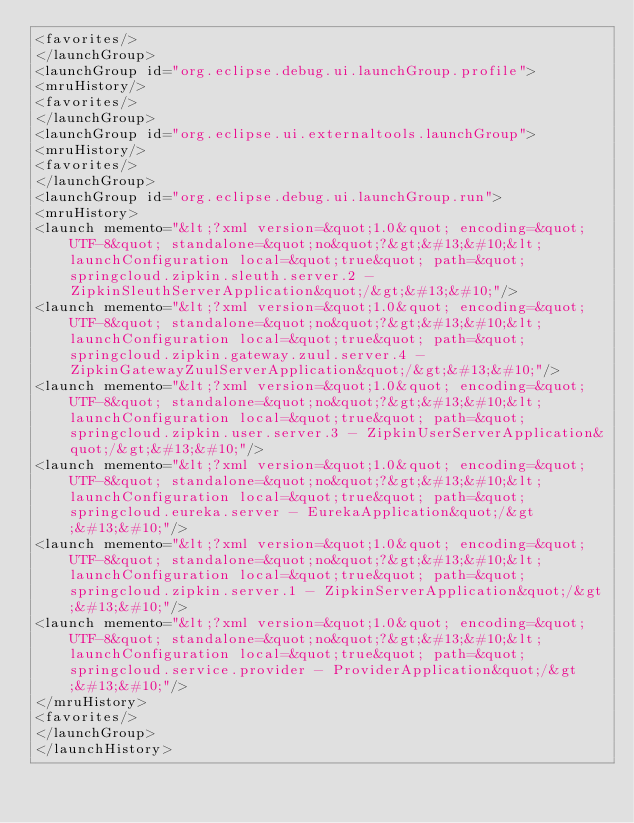Convert code to text. <code><loc_0><loc_0><loc_500><loc_500><_XML_><favorites/>
</launchGroup>
<launchGroup id="org.eclipse.debug.ui.launchGroup.profile">
<mruHistory/>
<favorites/>
</launchGroup>
<launchGroup id="org.eclipse.ui.externaltools.launchGroup">
<mruHistory/>
<favorites/>
</launchGroup>
<launchGroup id="org.eclipse.debug.ui.launchGroup.run">
<mruHistory>
<launch memento="&lt;?xml version=&quot;1.0&quot; encoding=&quot;UTF-8&quot; standalone=&quot;no&quot;?&gt;&#13;&#10;&lt;launchConfiguration local=&quot;true&quot; path=&quot;springcloud.zipkin.sleuth.server.2 - ZipkinSleuthServerApplication&quot;/&gt;&#13;&#10;"/>
<launch memento="&lt;?xml version=&quot;1.0&quot; encoding=&quot;UTF-8&quot; standalone=&quot;no&quot;?&gt;&#13;&#10;&lt;launchConfiguration local=&quot;true&quot; path=&quot;springcloud.zipkin.gateway.zuul.server.4 - ZipkinGatewayZuulServerApplication&quot;/&gt;&#13;&#10;"/>
<launch memento="&lt;?xml version=&quot;1.0&quot; encoding=&quot;UTF-8&quot; standalone=&quot;no&quot;?&gt;&#13;&#10;&lt;launchConfiguration local=&quot;true&quot; path=&quot;springcloud.zipkin.user.server.3 - ZipkinUserServerApplication&quot;/&gt;&#13;&#10;"/>
<launch memento="&lt;?xml version=&quot;1.0&quot; encoding=&quot;UTF-8&quot; standalone=&quot;no&quot;?&gt;&#13;&#10;&lt;launchConfiguration local=&quot;true&quot; path=&quot;springcloud.eureka.server - EurekaApplication&quot;/&gt;&#13;&#10;"/>
<launch memento="&lt;?xml version=&quot;1.0&quot; encoding=&quot;UTF-8&quot; standalone=&quot;no&quot;?&gt;&#13;&#10;&lt;launchConfiguration local=&quot;true&quot; path=&quot;springcloud.zipkin.server.1 - ZipkinServerApplication&quot;/&gt;&#13;&#10;"/>
<launch memento="&lt;?xml version=&quot;1.0&quot; encoding=&quot;UTF-8&quot; standalone=&quot;no&quot;?&gt;&#13;&#10;&lt;launchConfiguration local=&quot;true&quot; path=&quot;springcloud.service.provider - ProviderApplication&quot;/&gt;&#13;&#10;"/>
</mruHistory>
<favorites/>
</launchGroup>
</launchHistory>
</code> 